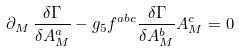Convert formula to latex. <formula><loc_0><loc_0><loc_500><loc_500>\partial _ { M } \, \frac { \delta \Gamma } { \delta A ^ { a } _ { M } } - g _ { 5 } f ^ { a b c } \frac { \delta \Gamma } { \delta A ^ { b } _ { M } } A ^ { c } _ { M } = 0</formula> 